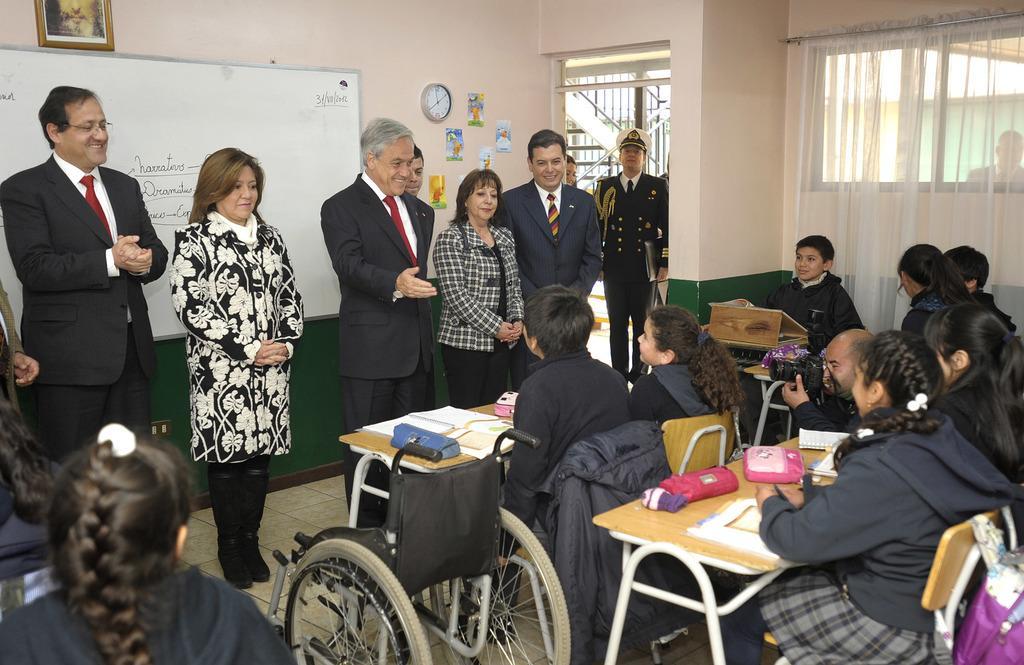In one or two sentences, can you explain what this image depicts? In this picture we can see some people are standing and some people are sitting in front of tables, we can see books and pouches on these tables, there is a wheel chair in the middle, in the background there is a wall, we can see a board, a photo frame, a watch and some stickers on the wall, on the right side there is a curtain. 